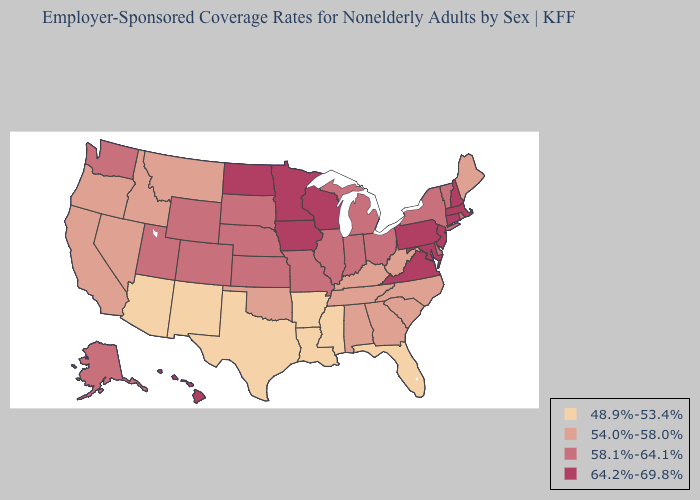Among the states that border Massachusetts , does Vermont have the lowest value?
Concise answer only. Yes. What is the highest value in the Northeast ?
Short answer required. 64.2%-69.8%. What is the value of Georgia?
Be succinct. 54.0%-58.0%. Does the first symbol in the legend represent the smallest category?
Short answer required. Yes. Does Illinois have a higher value than Maryland?
Answer briefly. No. What is the lowest value in the Northeast?
Write a very short answer. 54.0%-58.0%. Which states have the lowest value in the West?
Be succinct. Arizona, New Mexico. Does Pennsylvania have the highest value in the USA?
Be succinct. Yes. Name the states that have a value in the range 58.1%-64.1%?
Short answer required. Alaska, Colorado, Delaware, Illinois, Indiana, Kansas, Michigan, Missouri, Nebraska, New York, Ohio, Rhode Island, South Dakota, Utah, Vermont, Washington, Wyoming. Among the states that border North Dakota , does South Dakota have the highest value?
Keep it brief. No. Among the states that border South Dakota , does Montana have the highest value?
Keep it brief. No. Name the states that have a value in the range 54.0%-58.0%?
Concise answer only. Alabama, California, Georgia, Idaho, Kentucky, Maine, Montana, Nevada, North Carolina, Oklahoma, Oregon, South Carolina, Tennessee, West Virginia. Does New Hampshire have the highest value in the USA?
Write a very short answer. Yes. Which states have the lowest value in the MidWest?
Concise answer only. Illinois, Indiana, Kansas, Michigan, Missouri, Nebraska, Ohio, South Dakota. What is the value of Wyoming?
Answer briefly. 58.1%-64.1%. 